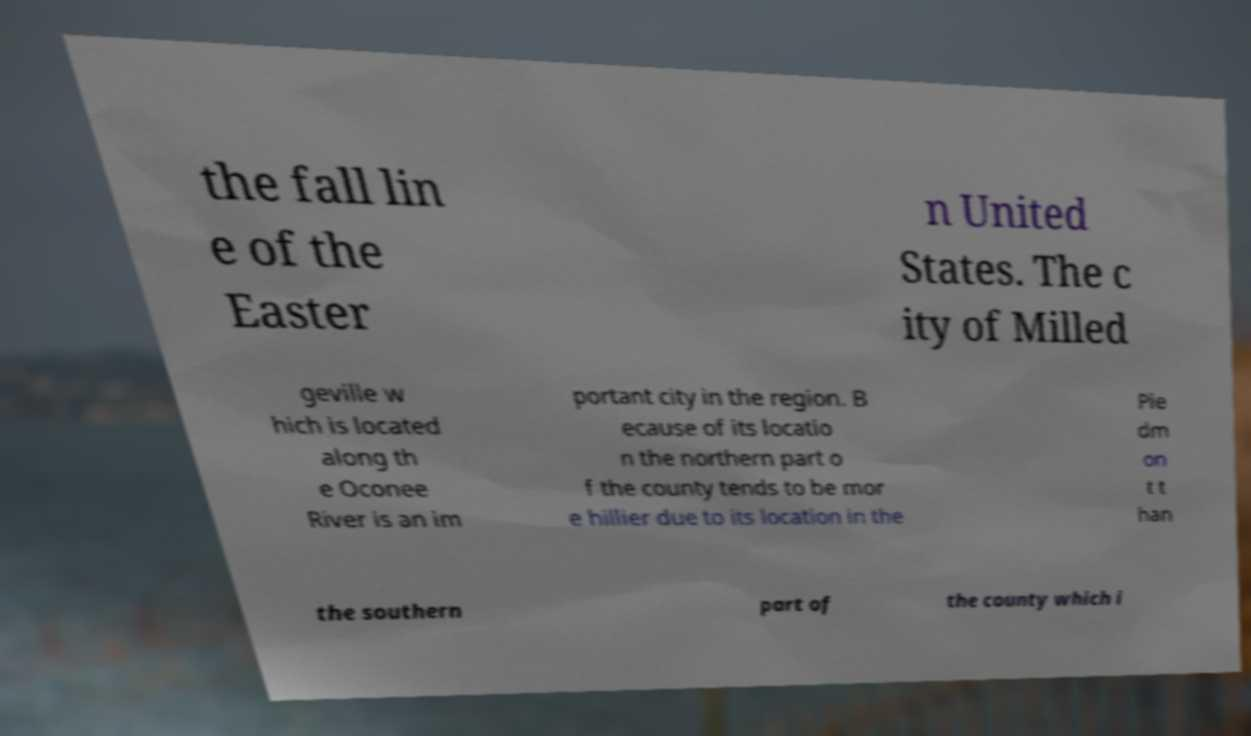Can you read and provide the text displayed in the image?This photo seems to have some interesting text. Can you extract and type it out for me? the fall lin e of the Easter n United States. The c ity of Milled geville w hich is located along th e Oconee River is an im portant city in the region. B ecause of its locatio n the northern part o f the county tends to be mor e hillier due to its location in the Pie dm on t t han the southern part of the county which i 